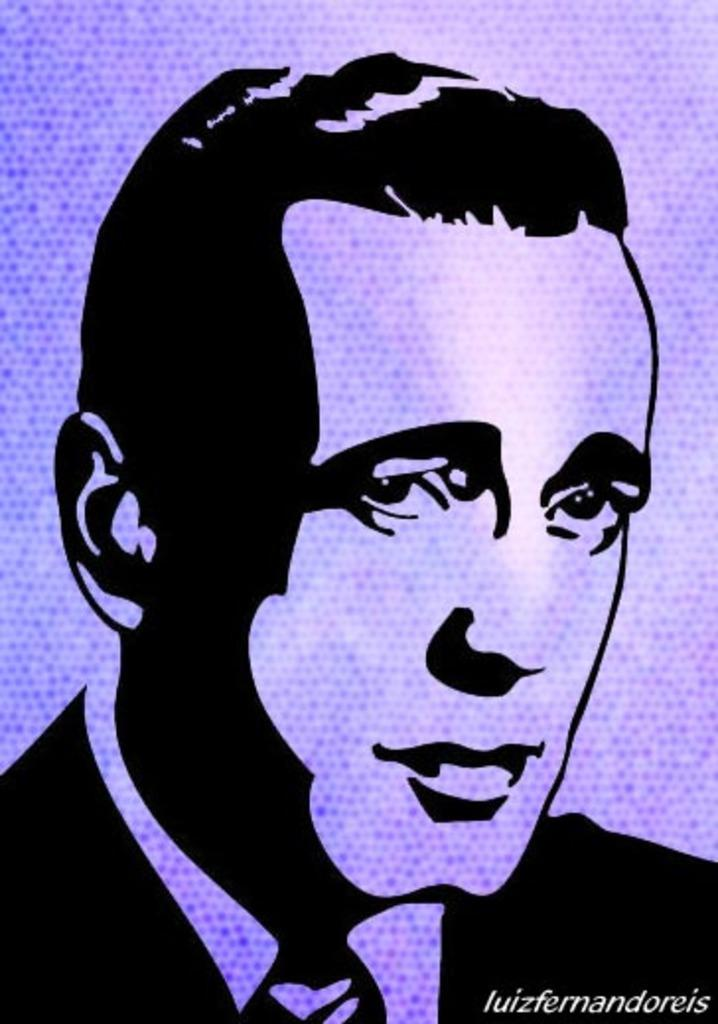What is depicted on the poster in the image? The poster contains a painting of a man's face. What color is the man's face in the painting? The man's face is in black color. What is the color of the background in the poster? The background of the poster is purple in color. Is there a calendar with a flame on the man's face in the image? No, there is no calendar or flame present on the man's face in the image. 